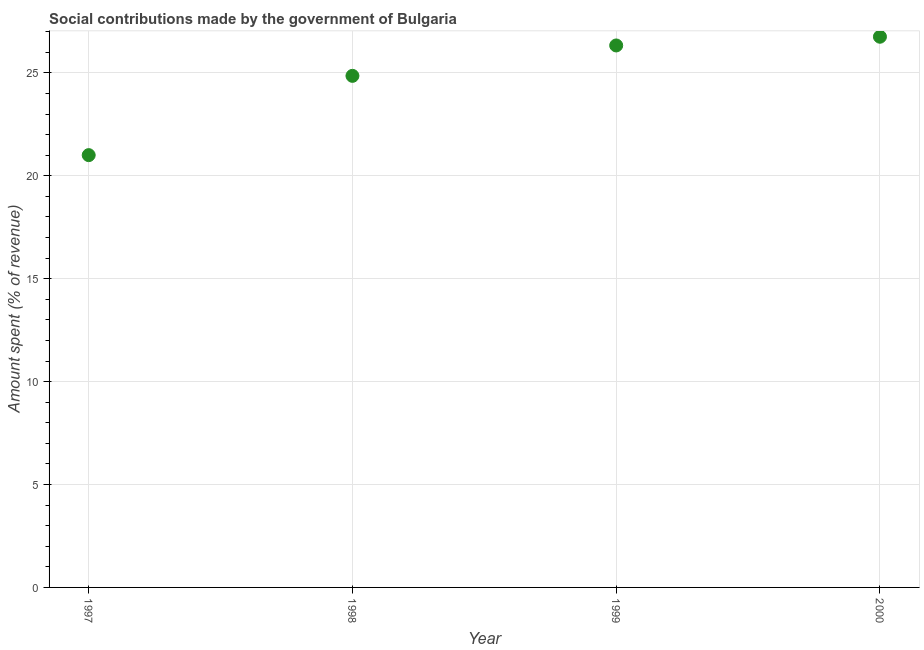What is the amount spent in making social contributions in 1997?
Your response must be concise. 21. Across all years, what is the maximum amount spent in making social contributions?
Keep it short and to the point. 26.75. Across all years, what is the minimum amount spent in making social contributions?
Ensure brevity in your answer.  21. In which year was the amount spent in making social contributions maximum?
Offer a terse response. 2000. What is the sum of the amount spent in making social contributions?
Offer a very short reply. 98.94. What is the difference between the amount spent in making social contributions in 1997 and 2000?
Provide a succinct answer. -5.75. What is the average amount spent in making social contributions per year?
Provide a succinct answer. 24.74. What is the median amount spent in making social contributions?
Offer a terse response. 25.59. In how many years, is the amount spent in making social contributions greater than 1 %?
Your answer should be very brief. 4. What is the ratio of the amount spent in making social contributions in 1997 to that in 1998?
Provide a short and direct response. 0.85. What is the difference between the highest and the second highest amount spent in making social contributions?
Make the answer very short. 0.42. What is the difference between the highest and the lowest amount spent in making social contributions?
Make the answer very short. 5.75. Does the amount spent in making social contributions monotonically increase over the years?
Keep it short and to the point. Yes. Does the graph contain grids?
Provide a short and direct response. Yes. What is the title of the graph?
Give a very brief answer. Social contributions made by the government of Bulgaria. What is the label or title of the X-axis?
Offer a terse response. Year. What is the label or title of the Y-axis?
Give a very brief answer. Amount spent (% of revenue). What is the Amount spent (% of revenue) in 1997?
Make the answer very short. 21. What is the Amount spent (% of revenue) in 1998?
Your response must be concise. 24.85. What is the Amount spent (% of revenue) in 1999?
Keep it short and to the point. 26.33. What is the Amount spent (% of revenue) in 2000?
Provide a short and direct response. 26.75. What is the difference between the Amount spent (% of revenue) in 1997 and 1998?
Your answer should be very brief. -3.85. What is the difference between the Amount spent (% of revenue) in 1997 and 1999?
Keep it short and to the point. -5.33. What is the difference between the Amount spent (% of revenue) in 1997 and 2000?
Offer a terse response. -5.75. What is the difference between the Amount spent (% of revenue) in 1998 and 1999?
Ensure brevity in your answer.  -1.48. What is the difference between the Amount spent (% of revenue) in 1998 and 2000?
Your answer should be compact. -1.9. What is the difference between the Amount spent (% of revenue) in 1999 and 2000?
Give a very brief answer. -0.42. What is the ratio of the Amount spent (% of revenue) in 1997 to that in 1998?
Your response must be concise. 0.84. What is the ratio of the Amount spent (% of revenue) in 1997 to that in 1999?
Provide a short and direct response. 0.8. What is the ratio of the Amount spent (% of revenue) in 1997 to that in 2000?
Provide a succinct answer. 0.79. What is the ratio of the Amount spent (% of revenue) in 1998 to that in 1999?
Offer a very short reply. 0.94. What is the ratio of the Amount spent (% of revenue) in 1998 to that in 2000?
Offer a terse response. 0.93. What is the ratio of the Amount spent (% of revenue) in 1999 to that in 2000?
Ensure brevity in your answer.  0.98. 